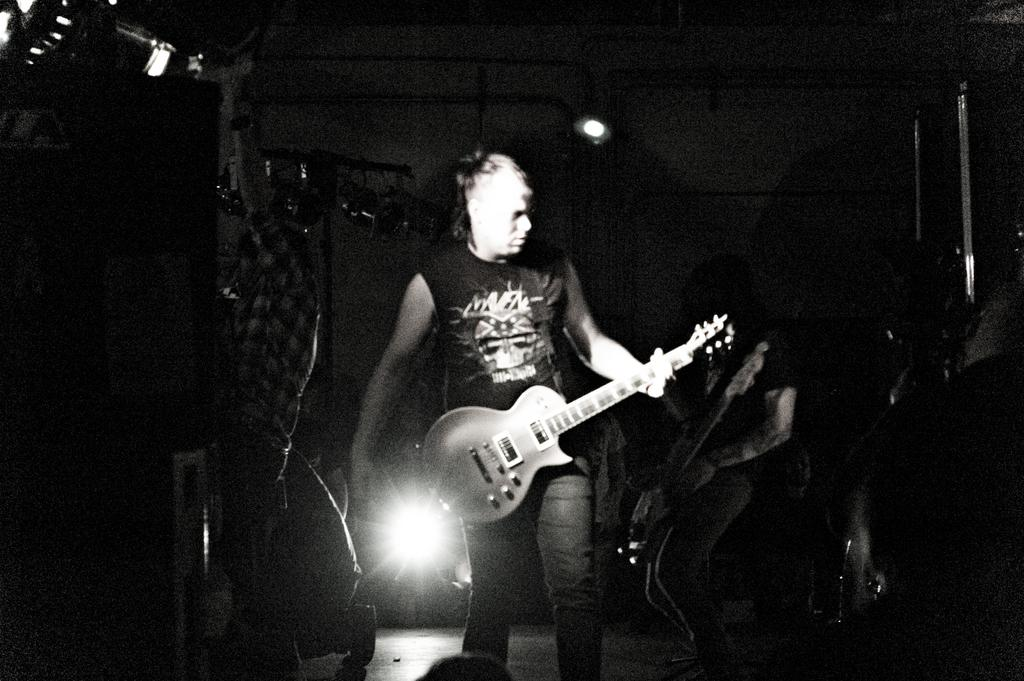What is the main subject of the image? The main subject of the image is a man. What is the man doing in the image? The man is playing a guitar in the image. What type of cast can be seen on the man's arm in the image? There is no cast visible on the man's arm in the image. How does the man's digestion affect his guitar playing in the image? There is no information about the man's digestion in the image, and it does not affect his guitar playing. 